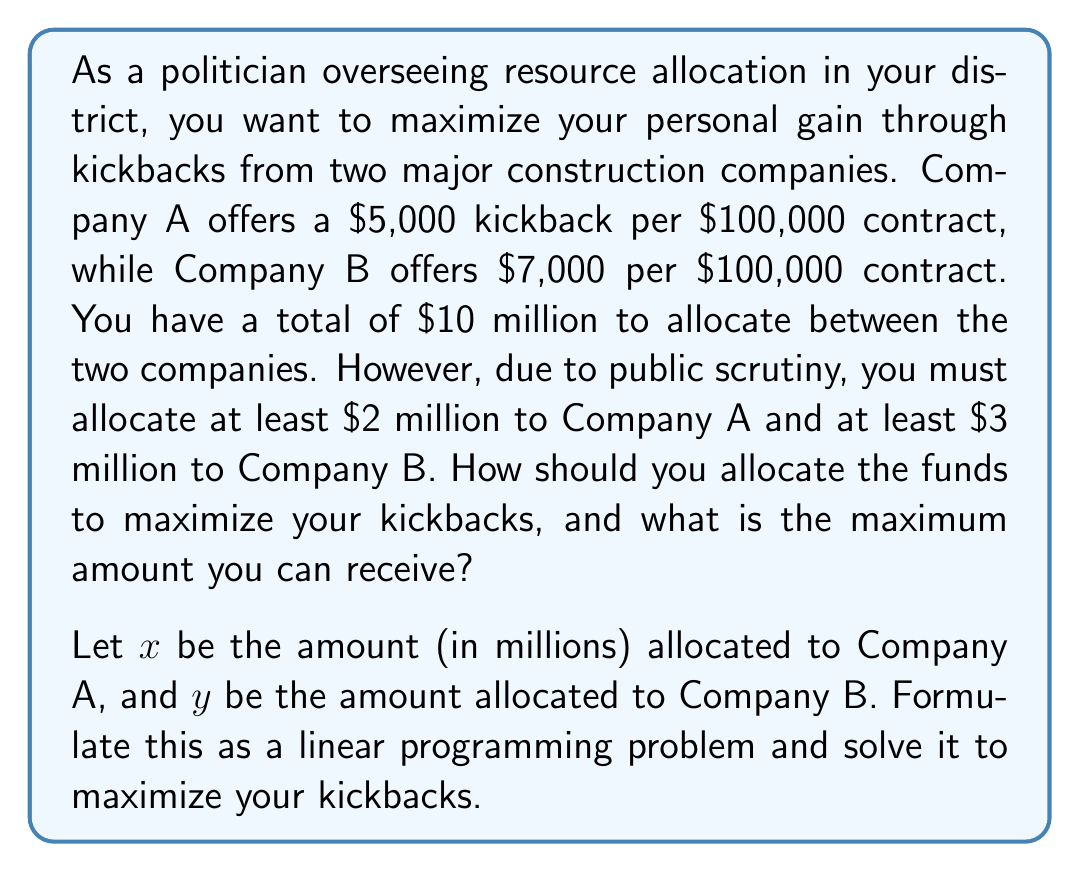Can you answer this question? To solve this linear programming problem, we need to:
1. Define the objective function
2. Identify the constraints
3. Set up the linear programming problem
4. Solve using the graphical method

1. Objective function:
   Let $z$ be the total kickbacks in thousands of dollars.
   Company A: $50x$ (5,000 per million)
   Company B: $70y$ (7,000 per million)
   $$z = 50x + 70y$$

2. Constraints:
   Total budget: $x + y \leq 10$
   Minimum for Company A: $x \geq 2$
   Minimum for Company B: $y \geq 3$
   Non-negativity: $x \geq 0$, $y \geq 0$

3. Linear programming problem:
   Maximize $z = 50x + 70y$
   Subject to:
   $$\begin{align*}
   x + y &\leq 10 \\
   x &\geq 2 \\
   y &\geq 3 \\
   x, y &\geq 0
   \end{align*}$$

4. Solving graphically:
   The feasible region is bounded by the lines:
   $x + y = 10$, $x = 2$, and $y = 3$

   The corners of the feasible region are:
   (2, 3), (2, 8), and (7, 3)

   Evaluating $z$ at each corner:
   (2, 3): $z = 50(2) + 70(3) = 310$
   (2, 8): $z = 50(2) + 70(8) = 660$
   (7, 3): $z = 50(7) + 70(3) = 560$

   The maximum value occurs at (2, 8), which means allocate $2 million to Company A and $8 million to Company B.
Answer: Optimal allocation: $2 million to Company A, $8 million to Company B
Maximum kickbacks: $660,000 